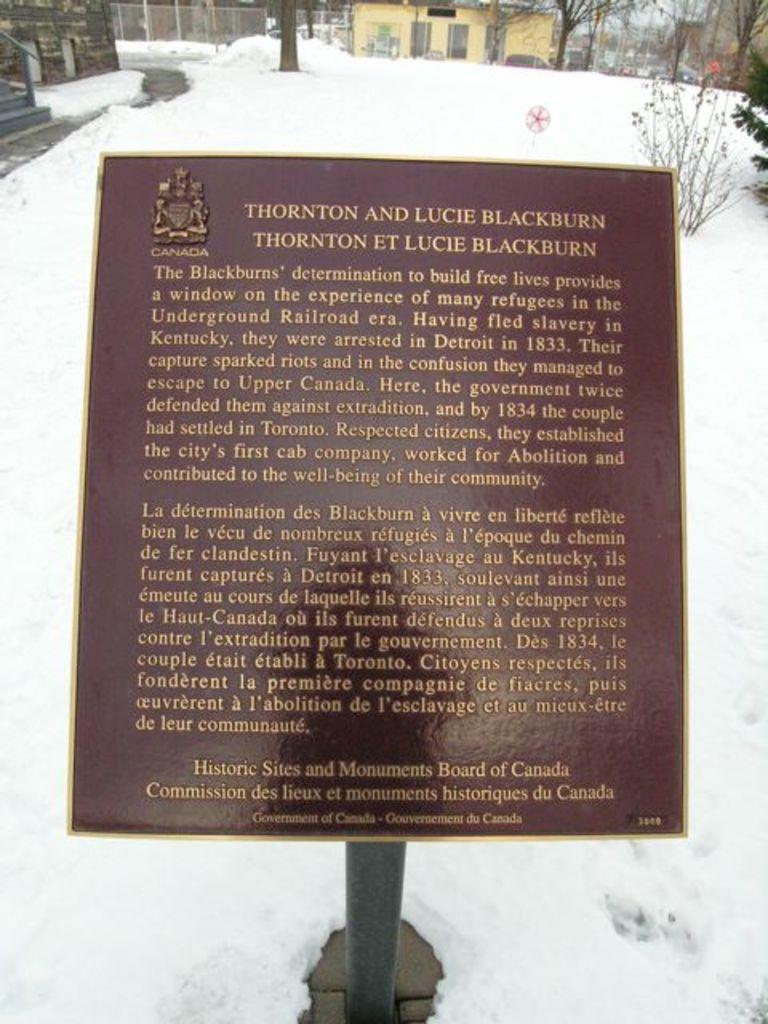Could you give a brief overview of what you see in this image? In the foreground of this picture, there is a name board and around it there is the snow. In the background, there is a plant, trees, houses, and a fencing. 